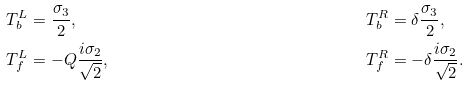Convert formula to latex. <formula><loc_0><loc_0><loc_500><loc_500>T ^ { L } _ { b } & = \frac { \sigma _ { 3 } } { 2 } , & T ^ { R } _ { b } & = \delta \frac { \sigma _ { 3 } } { 2 } , \\ T ^ { L } _ { f } & = - Q \frac { i \sigma _ { 2 } } { \sqrt { 2 } } , & T ^ { R } _ { f } & = - \delta \frac { i \sigma _ { 2 } } { \sqrt { 2 } } .</formula> 